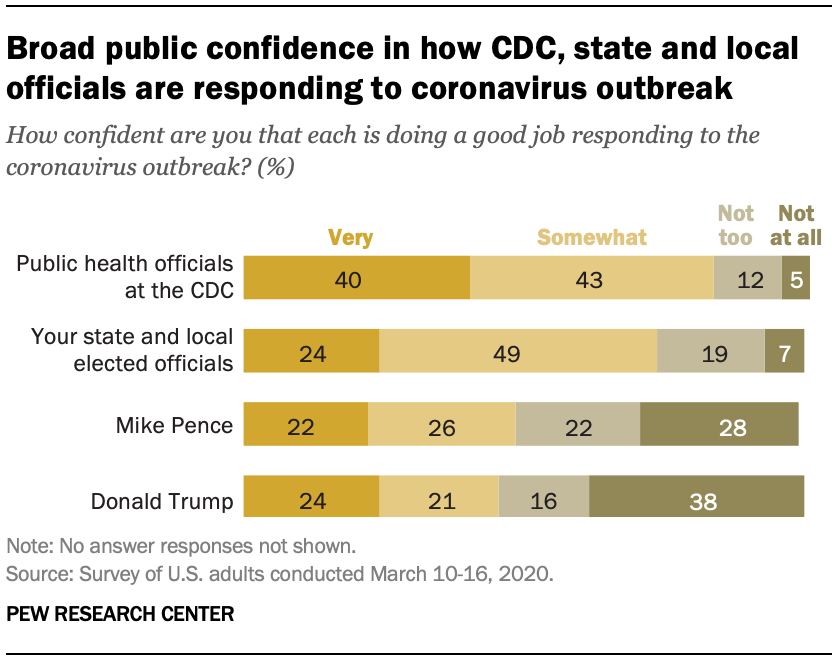Indicate a few pertinent items in this graphic. Forty-eight percent of people surveyed expressed at least some level of confidence that Mike Pence performed well in his role. A recent survey found that 24% of people expressed a high level of confidence that Trump did a good job as president. 